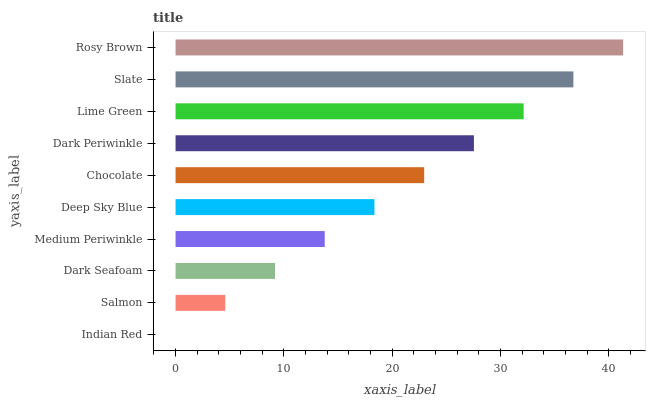Is Indian Red the minimum?
Answer yes or no. Yes. Is Rosy Brown the maximum?
Answer yes or no. Yes. Is Salmon the minimum?
Answer yes or no. No. Is Salmon the maximum?
Answer yes or no. No. Is Salmon greater than Indian Red?
Answer yes or no. Yes. Is Indian Red less than Salmon?
Answer yes or no. Yes. Is Indian Red greater than Salmon?
Answer yes or no. No. Is Salmon less than Indian Red?
Answer yes or no. No. Is Chocolate the high median?
Answer yes or no. Yes. Is Deep Sky Blue the low median?
Answer yes or no. Yes. Is Dark Seafoam the high median?
Answer yes or no. No. Is Rosy Brown the low median?
Answer yes or no. No. 